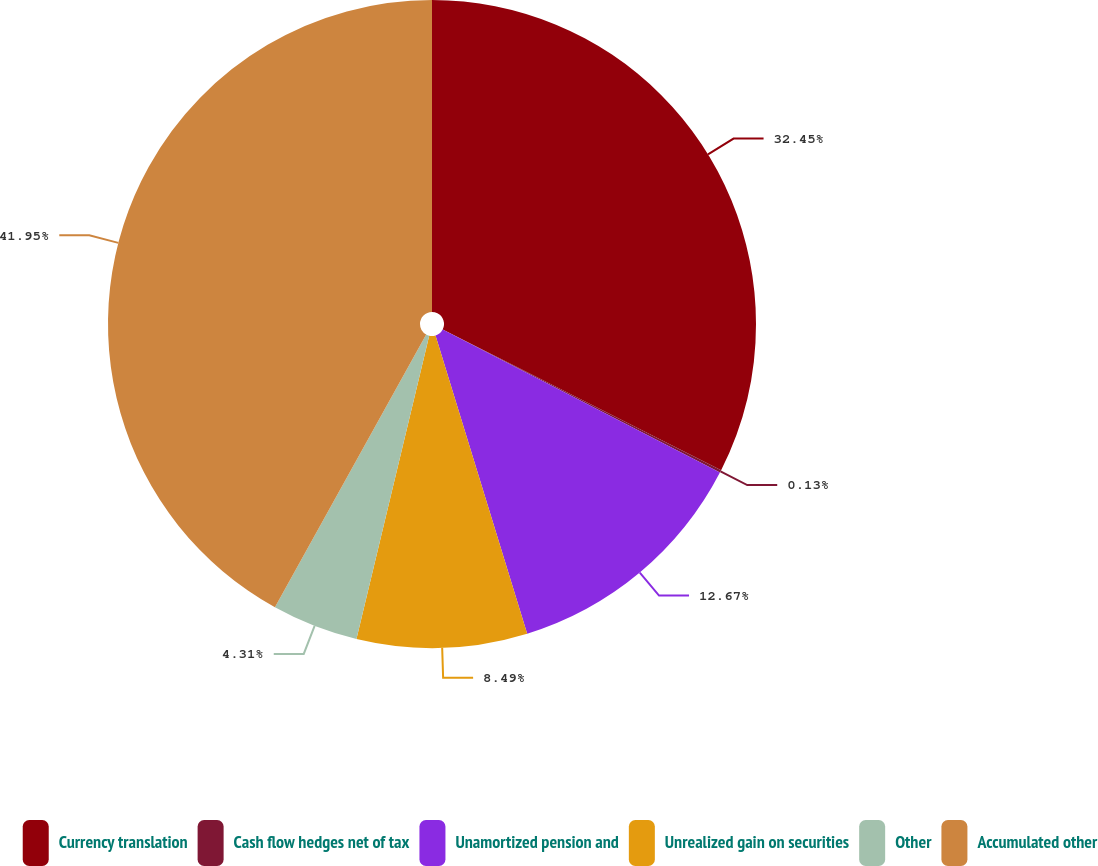<chart> <loc_0><loc_0><loc_500><loc_500><pie_chart><fcel>Currency translation<fcel>Cash flow hedges net of tax<fcel>Unamortized pension and<fcel>Unrealized gain on securities<fcel>Other<fcel>Accumulated other<nl><fcel>32.45%<fcel>0.13%<fcel>12.67%<fcel>8.49%<fcel>4.31%<fcel>41.94%<nl></chart> 